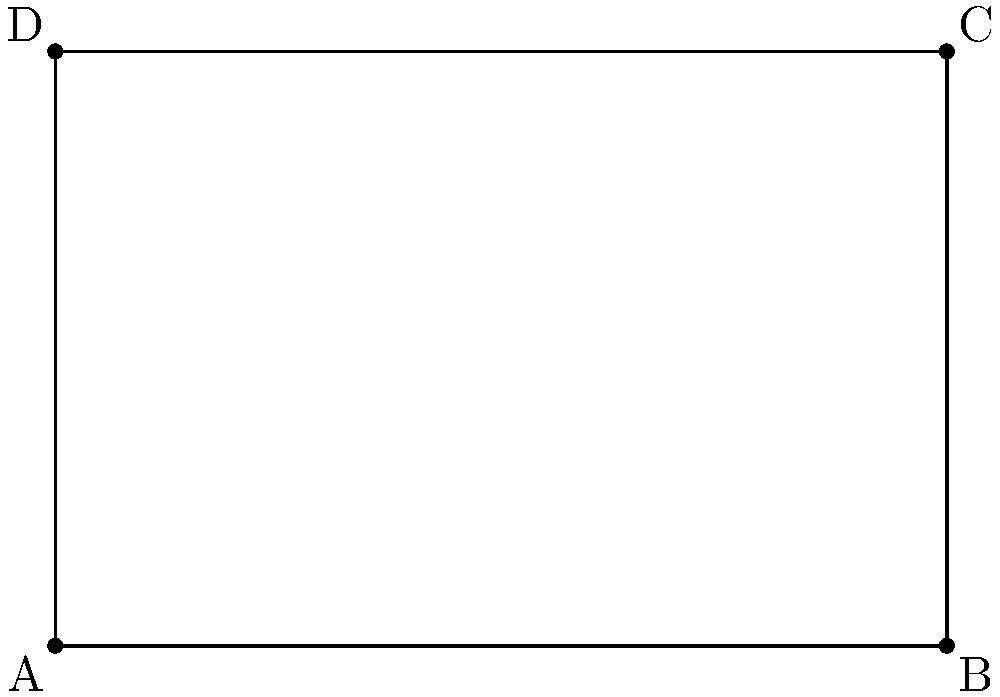Given a rectangle ABCD with vertices A(-2,-1), B(4,-1), C(4,3), and D(-2,3) on a coordinate plane, calculate its area. Why might different calculation methods yield varying results? To calculate the area of the rectangle, we can use two different methods:

1. Using the formula for the area of a rectangle:
   Area = length × width
   
   Step 1: Calculate the length (distance between A and B)
   $$\text{length} = |x_B - x_A| = |4 - (-2)| = 6$$
   
   Step 2: Calculate the width (distance between A and D)
   $$\text{width} = |y_D - y_A| = |3 - (-1)| = 4$$
   
   Step 3: Calculate the area
   $$\text{Area} = 6 \times 4 = 24$$

2. Using the shoelace formula (coordinate geometry method):
   $$\text{Area} = \frac{1}{2}|(x_A y_B + x_B y_C + x_C y_D + x_D y_A) - (y_A x_B + y_B x_C + y_C x_D + y_D x_A)|$$
   
   Step 1: Substitute the coordinates
   $$\text{Area} = \frac{1}{2}|[(-2 \times -1) + (4 \times 3) + (4 \times 3) + (-2 \times -1)] - [(-1 \times 4) + (-1 \times 4) + (3 \times -2) + (3 \times -2)]|$$
   
   Step 2: Simplify
   $$\text{Area} = \frac{1}{2}|(2 + 12 + 12 + 2) - (-4 - 4 - 6 - 6)|$$
   $$\text{Area} = \frac{1}{2}|28 - (-20)| = \frac{1}{2}|28 + 20| = \frac{1}{2} \times 48 = 24$$

Both methods yield the same result of 24 square units. However, different responses might occur due to:
1. Rounding errors in intermediate calculations
2. Misapplication of formulas
3. Confusion between absolute values and signed distances
4. Errors in coordinate reading or input
Answer: 24 square units 